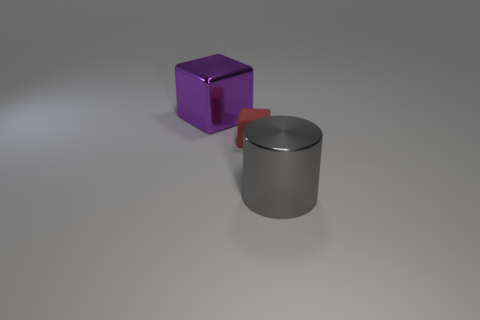Add 2 small matte things. How many objects exist? 5 Subtract all purple blocks. How many blocks are left? 1 Subtract all cubes. How many objects are left? 1 Subtract all shiny things. Subtract all gray metal cylinders. How many objects are left? 0 Add 1 rubber blocks. How many rubber blocks are left? 2 Add 3 small red cubes. How many small red cubes exist? 4 Subtract 0 red cylinders. How many objects are left? 3 